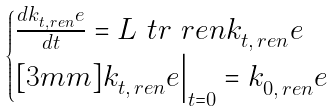<formula> <loc_0><loc_0><loc_500><loc_500>\begin{cases} \frac { d k _ { t , \, r e n } ^ { \ } e } { d t } = L ^ { \ } t r _ { \ } r e n k _ { t , \, r e n } ^ { \ } e \\ [ 3 m m ] k _ { t , \, r e n } ^ { \ } e \Big | _ { t = 0 } = k _ { 0 , \, r e n } ^ { \ } e \end{cases}</formula> 